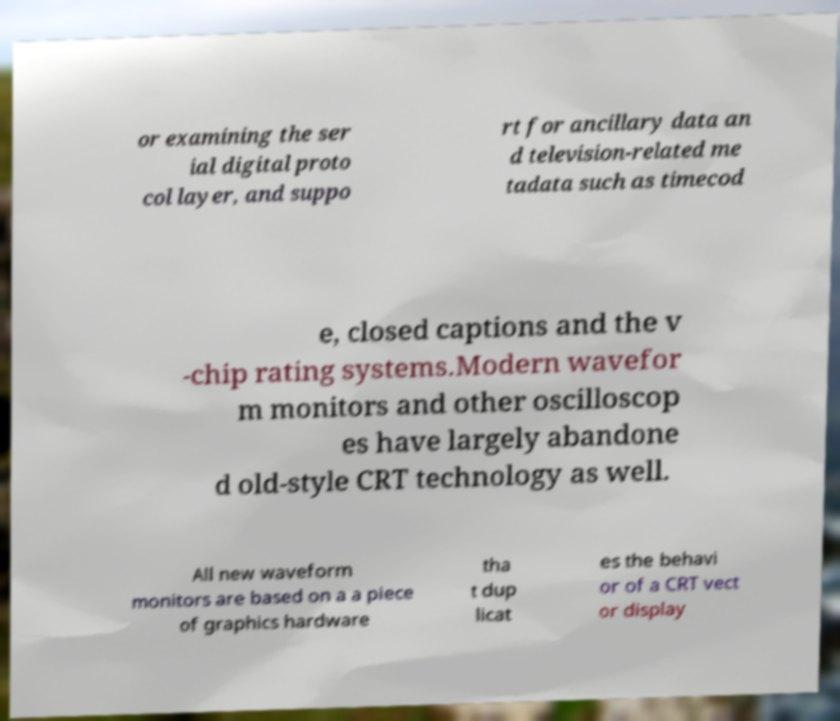Can you accurately transcribe the text from the provided image for me? or examining the ser ial digital proto col layer, and suppo rt for ancillary data an d television-related me tadata such as timecod e, closed captions and the v -chip rating systems.Modern wavefor m monitors and other oscilloscop es have largely abandone d old-style CRT technology as well. All new waveform monitors are based on a a piece of graphics hardware tha t dup licat es the behavi or of a CRT vect or display 